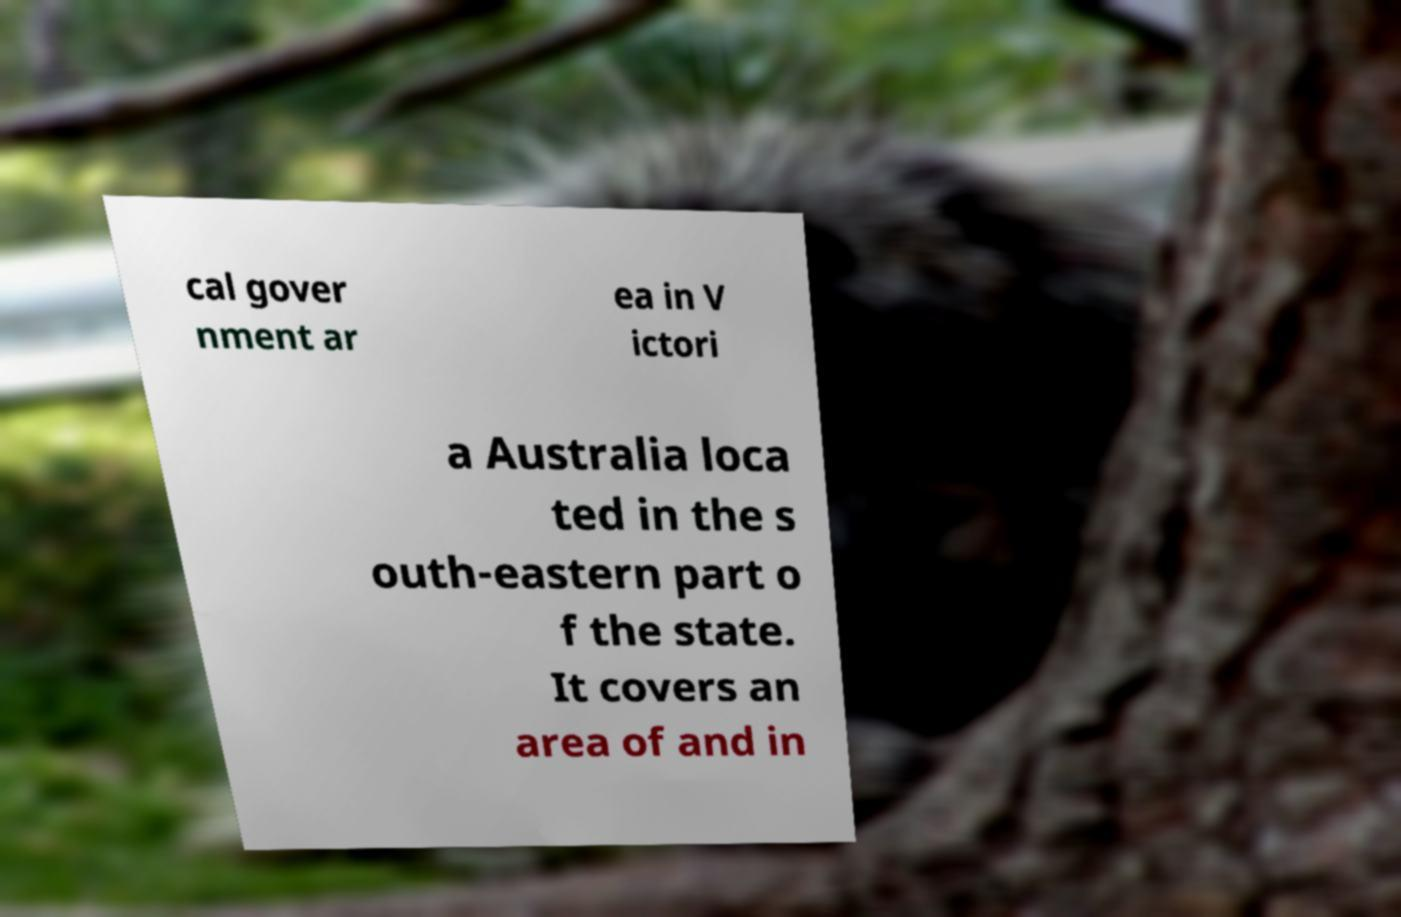Please read and relay the text visible in this image. What does it say? cal gover nment ar ea in V ictori a Australia loca ted in the s outh-eastern part o f the state. It covers an area of and in 